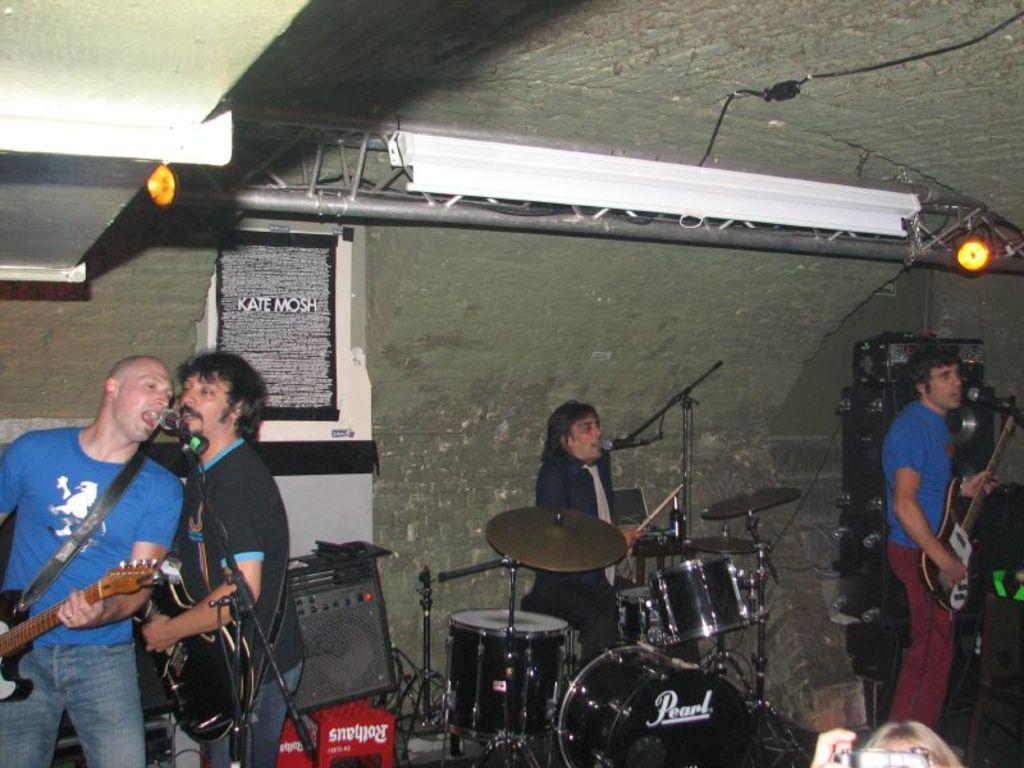Please provide a concise description of this image. In a room there are four persons. To the right side there is a man with blue t-shirt and maroon pant standing and playing guitar, in front of him there is a mic. In the middle there is another man with black jacket sitting and playing drums, in front of hi there is a mic. To the left side there is a man with blue t-shirt standing and playing guitar, in front of him there is a mic and he is singing. Beside him there is a man with black shirt standing and playing guitar. In the background there is a wall and to the top there is a speaker and to the bottom there is a black box. 